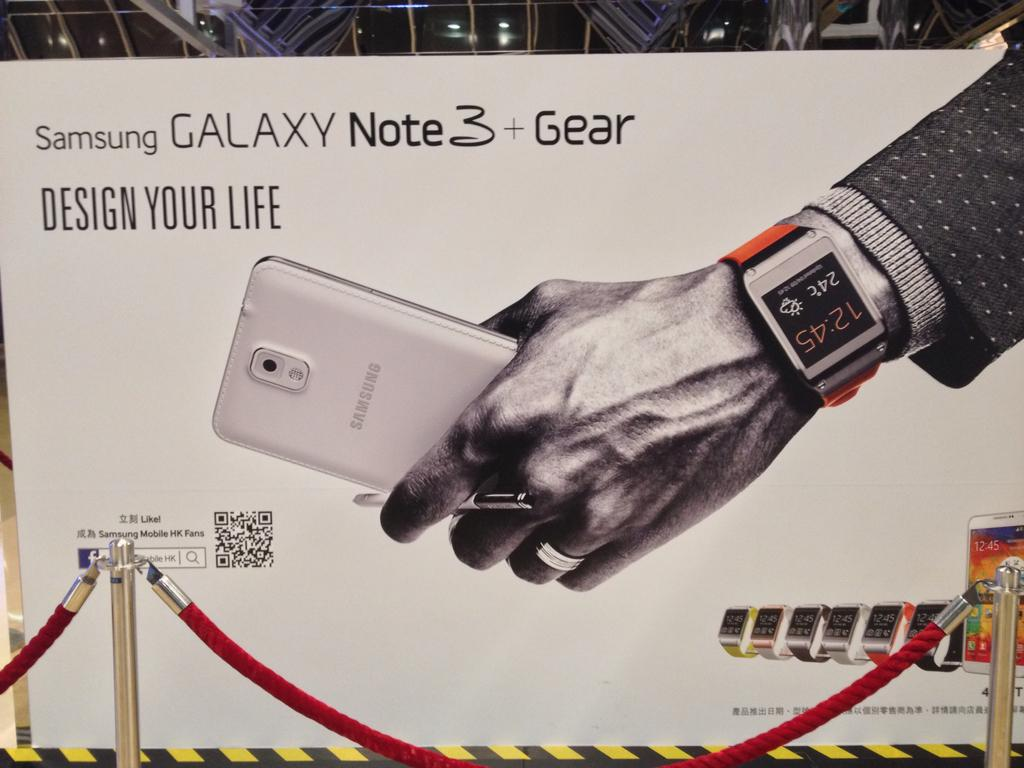<image>
Write a terse but informative summary of the picture. The phone advertised claims to be able to assist you to design your life. 